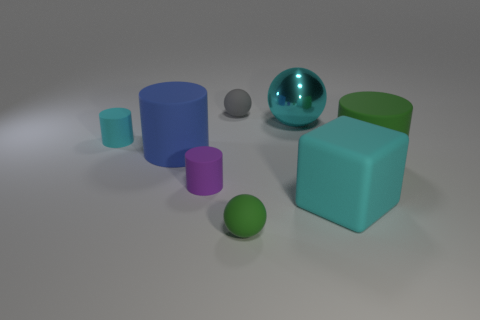What number of other things are there of the same material as the tiny green sphere
Offer a very short reply. 6. There is a cyan block that is the same size as the metal object; what is it made of?
Keep it short and to the point. Rubber. Do the green rubber thing to the right of the green matte ball and the green rubber object that is in front of the large green matte object have the same shape?
Make the answer very short. No. The cyan metal thing that is the same size as the cyan matte block is what shape?
Offer a terse response. Sphere. Do the big cylinder to the right of the blue rubber thing and the big blue cylinder that is on the left side of the big metallic sphere have the same material?
Provide a succinct answer. Yes. Is there a large blue cylinder that is behind the tiny matte cylinder that is behind the purple rubber thing?
Give a very brief answer. No. There is a big block that is the same material as the purple cylinder; what is its color?
Your answer should be compact. Cyan. Are there more tiny purple rubber cylinders than big matte objects?
Provide a short and direct response. No. What number of objects are cyan matte things on the right side of the gray matte object or small purple metal objects?
Your answer should be very brief. 1. Are there any gray rubber spheres that have the same size as the blue rubber cylinder?
Your response must be concise. No. 